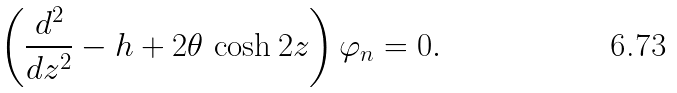<formula> <loc_0><loc_0><loc_500><loc_500>\left ( { \frac { d ^ { 2 } } { d z ^ { 2 } } } - h + 2 \theta \, \cosh 2 z \right ) \varphi _ { n } = 0 .</formula> 